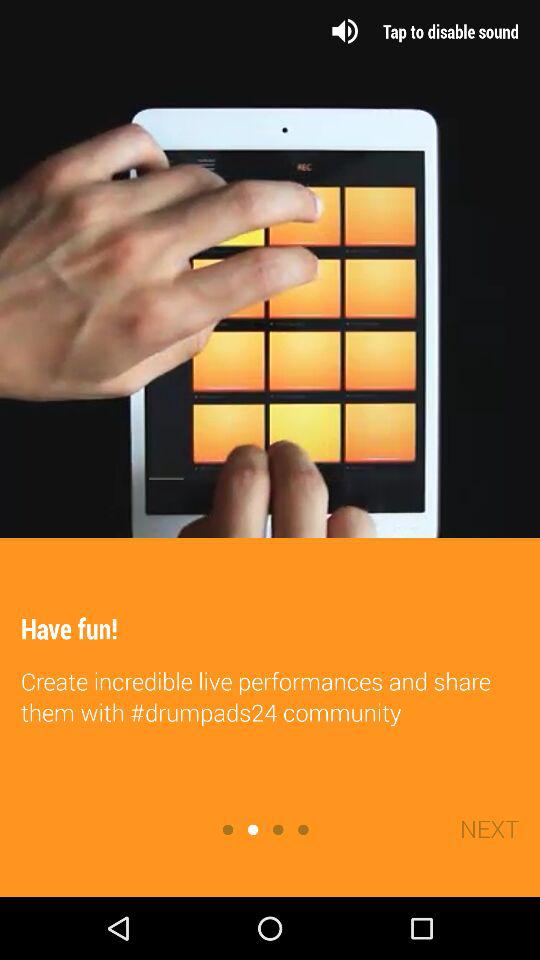What is the name of the application? The name of the application is "drumpads24". 